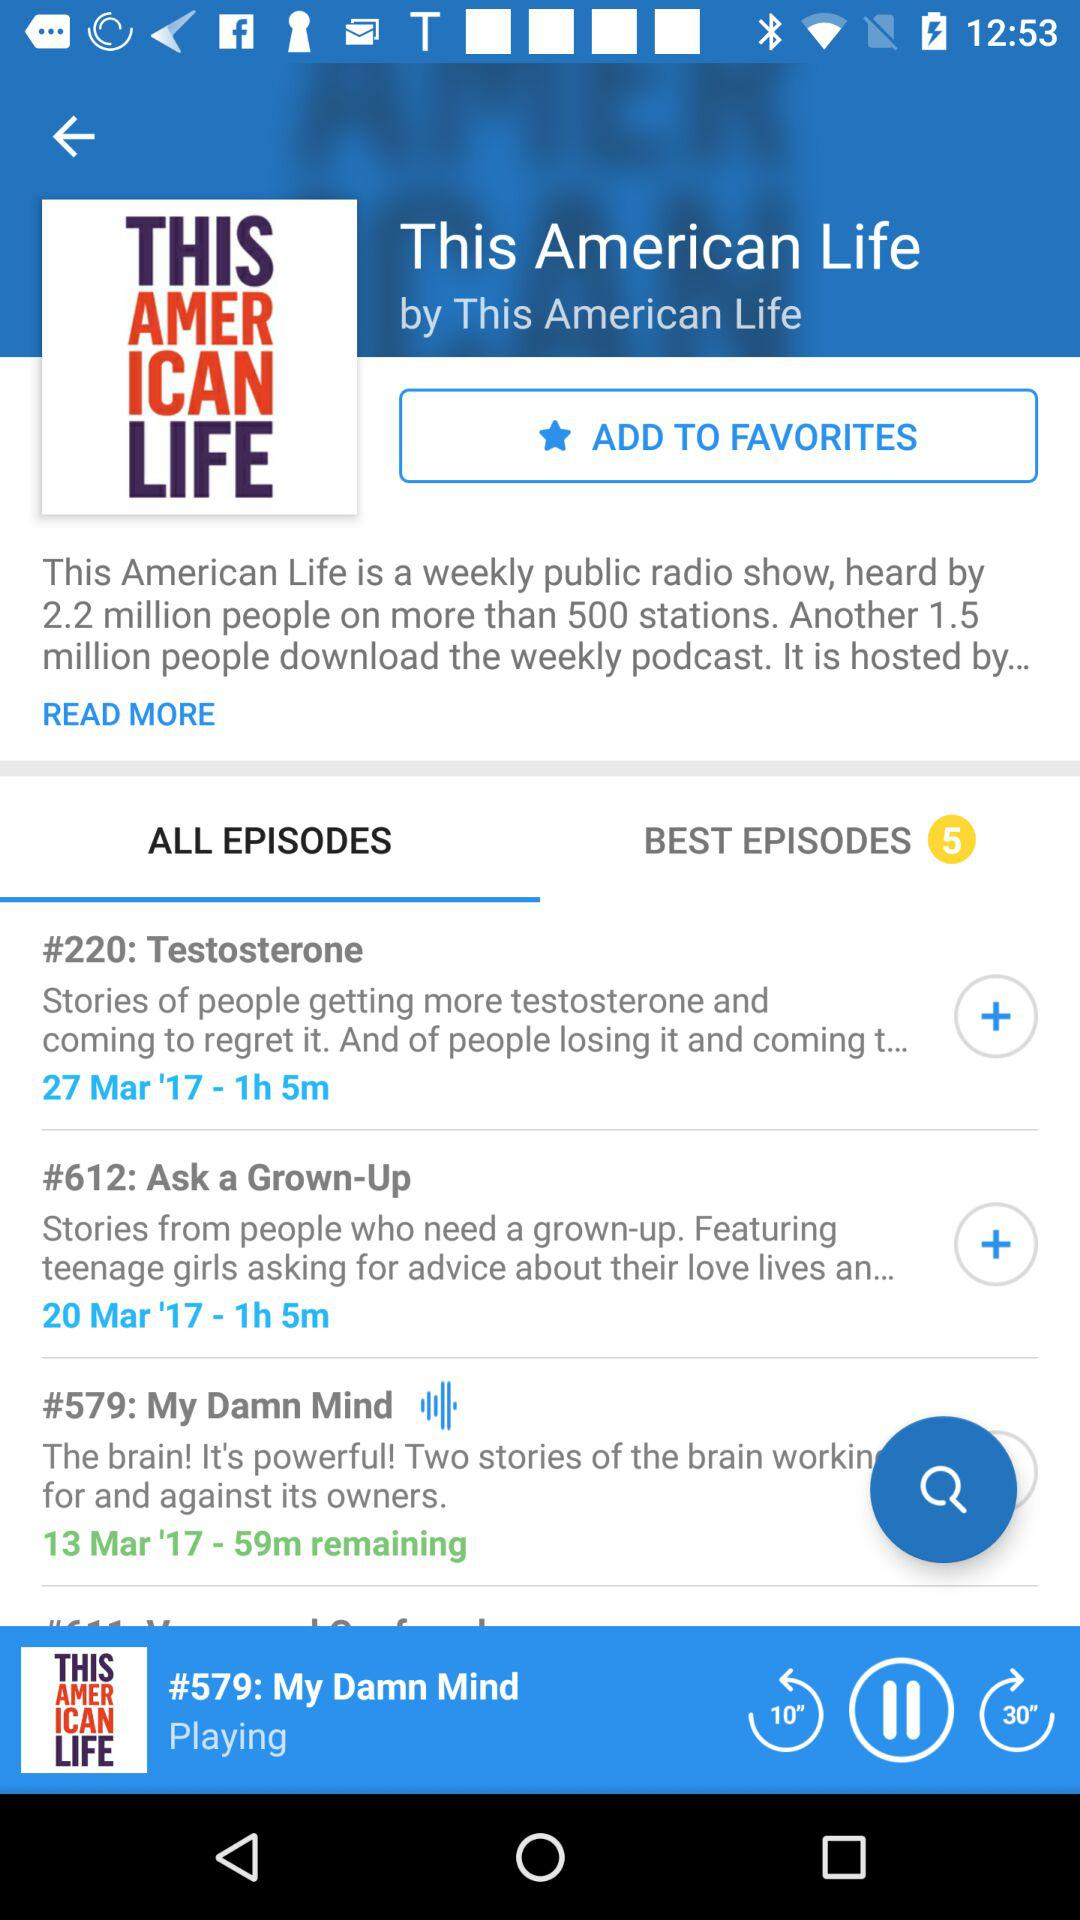Which episode is currently being played? The episode that is currently being played is "My Damn Mind". 